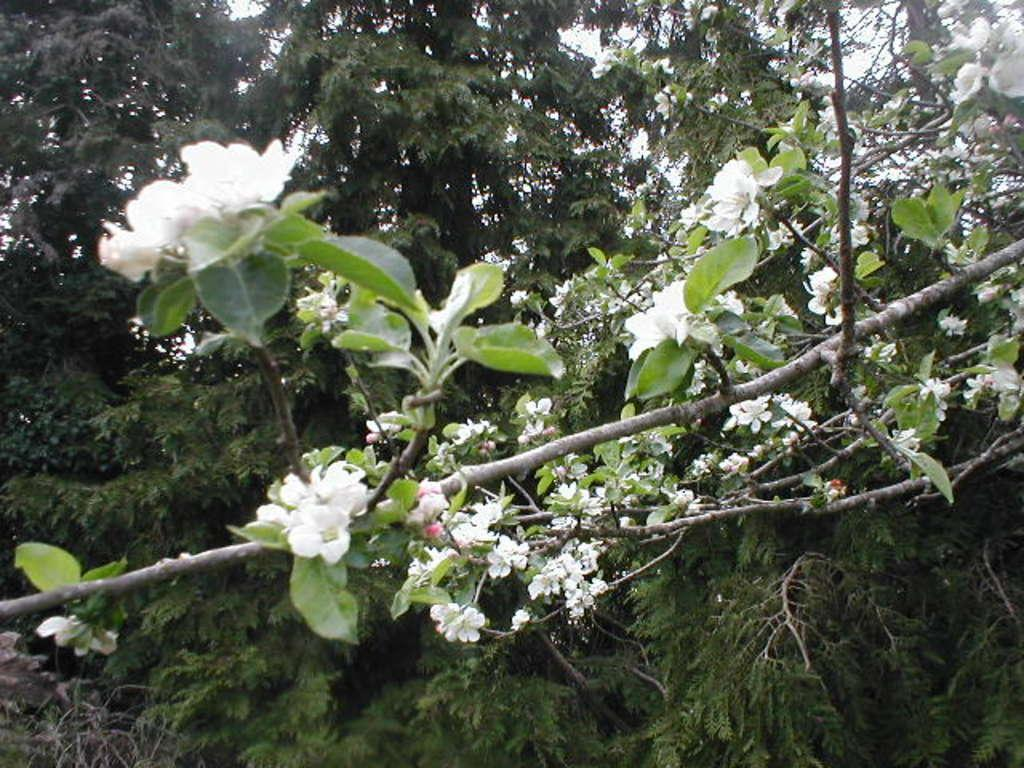What type of vegetation can be seen in the image? There are trees in the image. What color are the flowers that are visible in the image? There are white-colored flowers in the image. Can you tell me which actor is standing next to the trees in the image? There is no actor present in the image; it features trees and white-colored flowers. Is there a hole visible in the image? There is no hole present in the image; it features trees and white-colored flowers. 